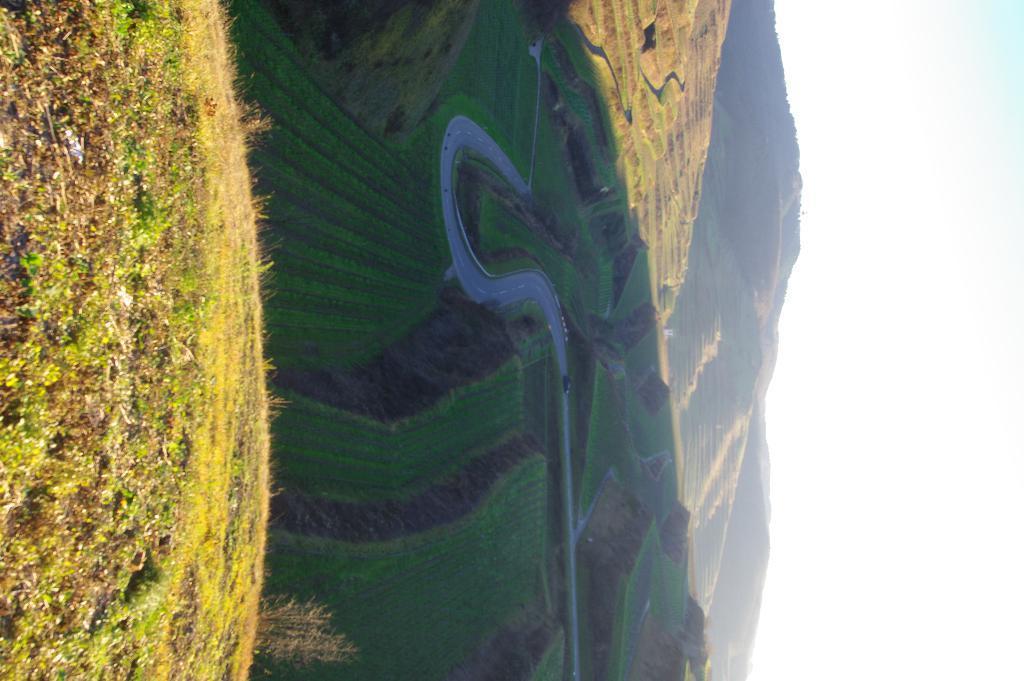Could you give a brief overview of what you see in this image? In this image we can see grass on the ground on the left side. In the background we can see road, grass, hills and clouds in the sky on the left side. 